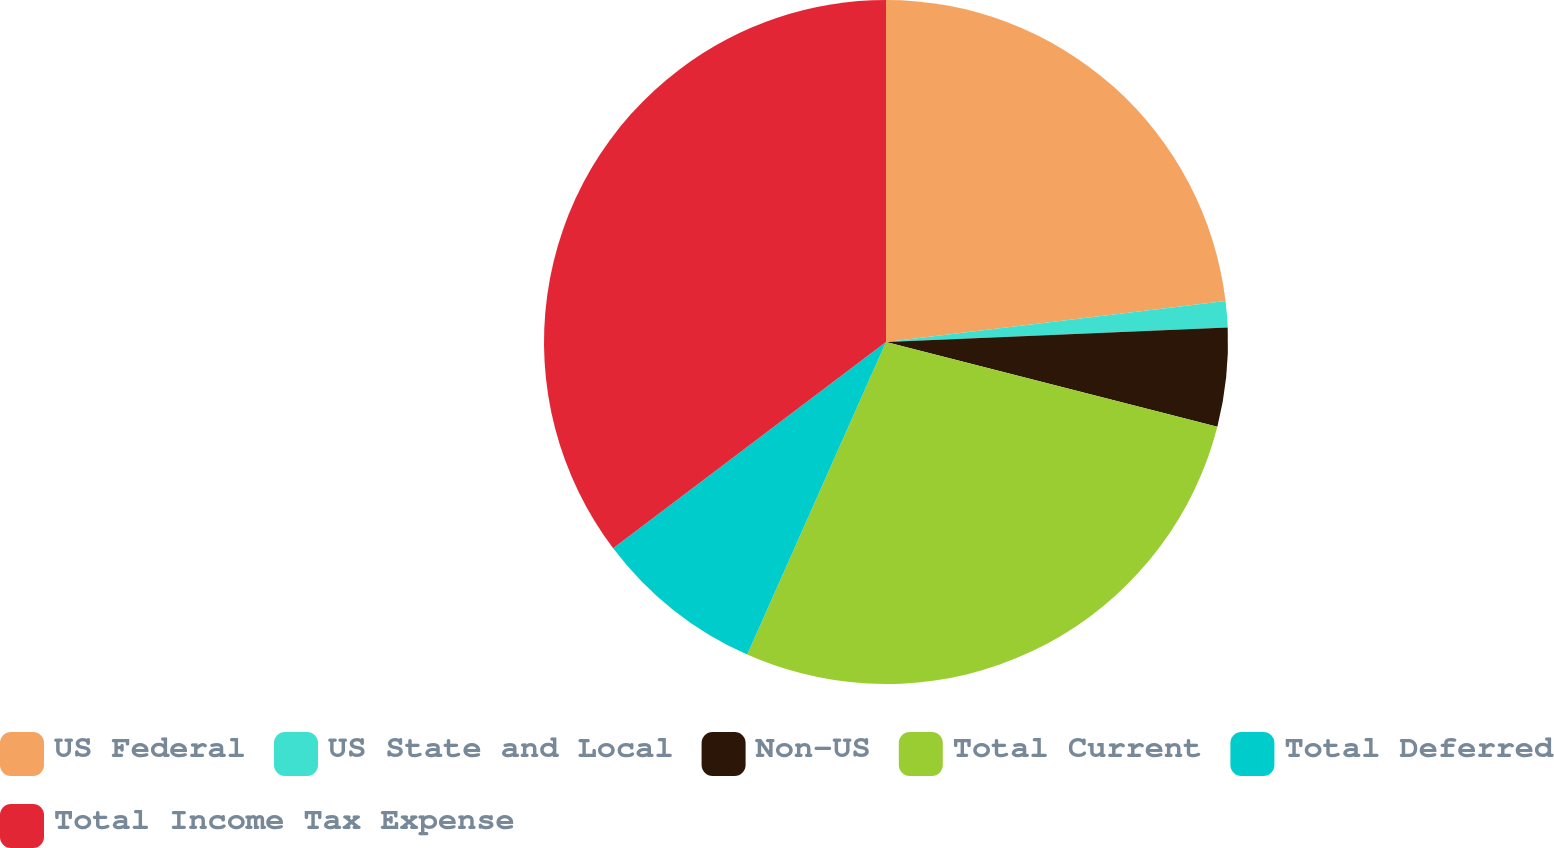Convert chart to OTSL. <chart><loc_0><loc_0><loc_500><loc_500><pie_chart><fcel>US Federal<fcel>US State and Local<fcel>Non-US<fcel>Total Current<fcel>Total Deferred<fcel>Total Income Tax Expense<nl><fcel>23.09%<fcel>1.24%<fcel>4.65%<fcel>27.67%<fcel>8.05%<fcel>35.3%<nl></chart> 